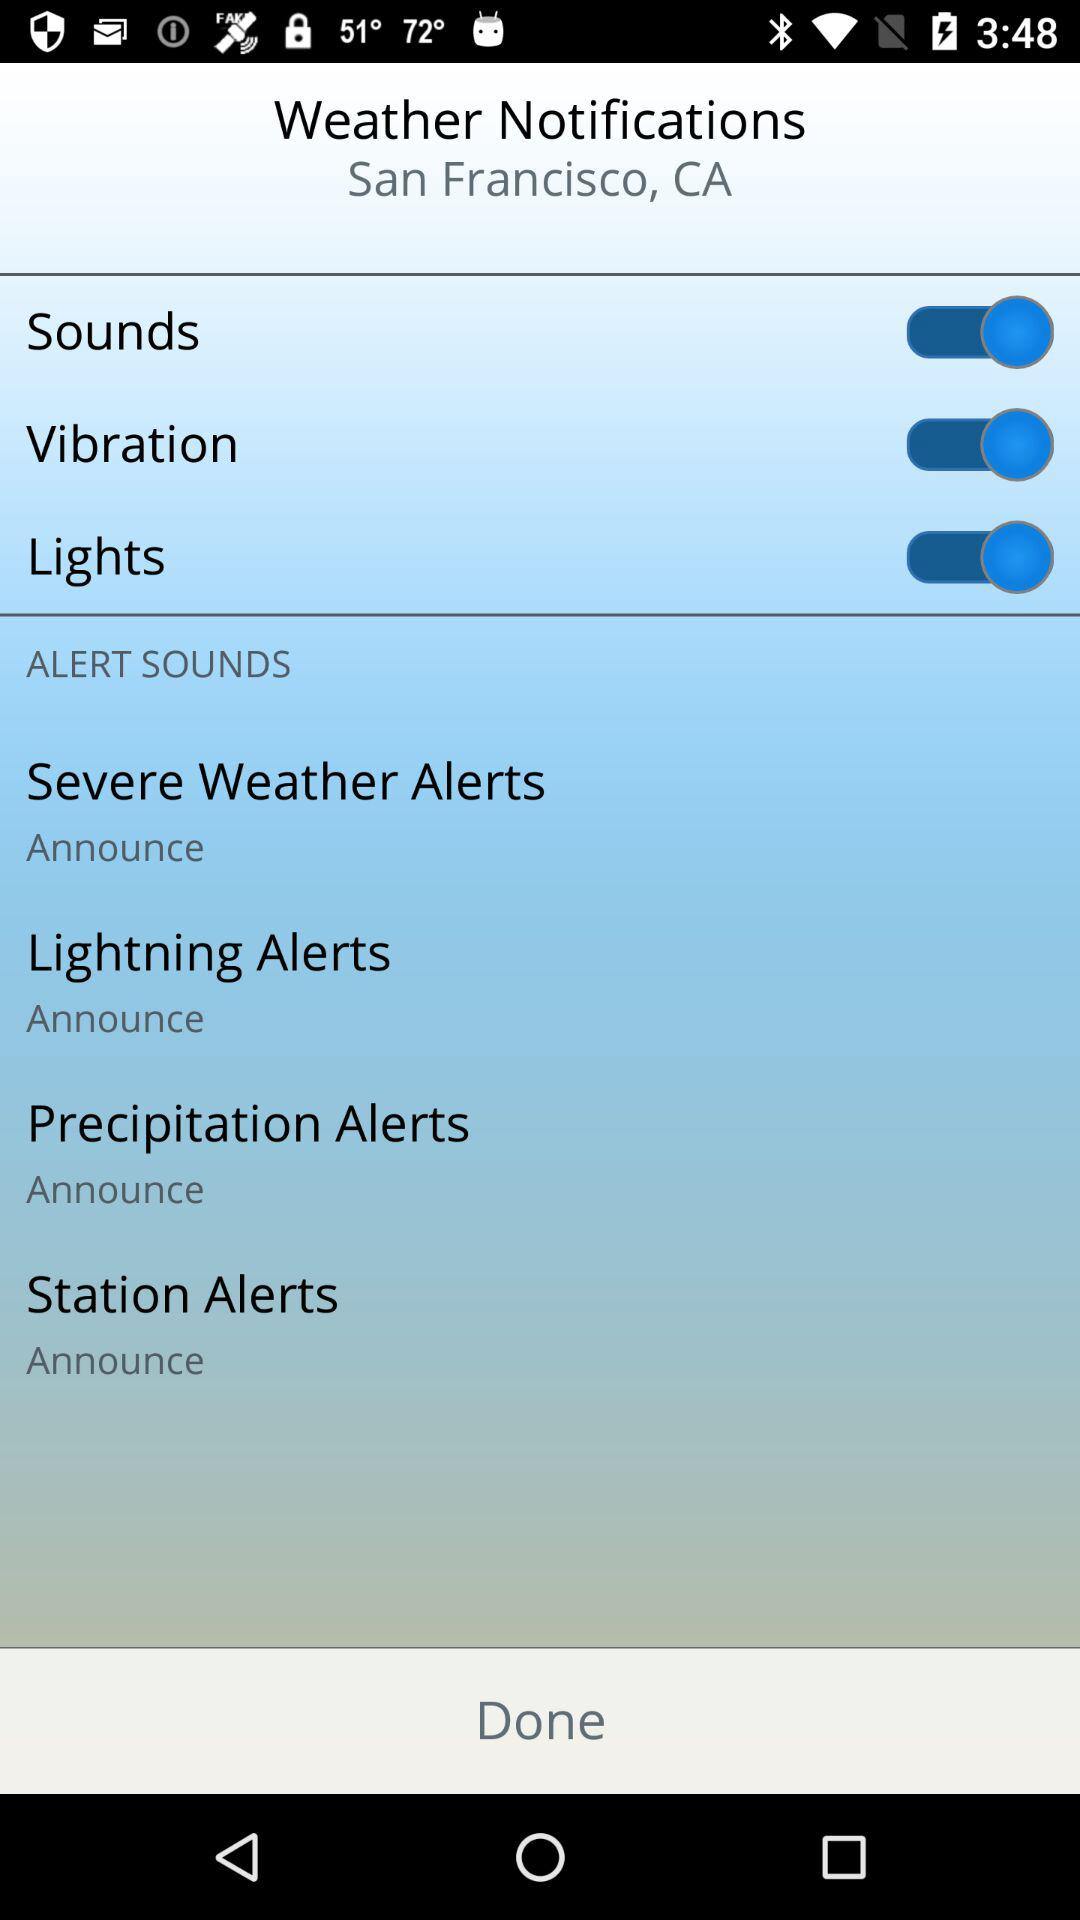What is the status of "Sounds"? The status is "on". 